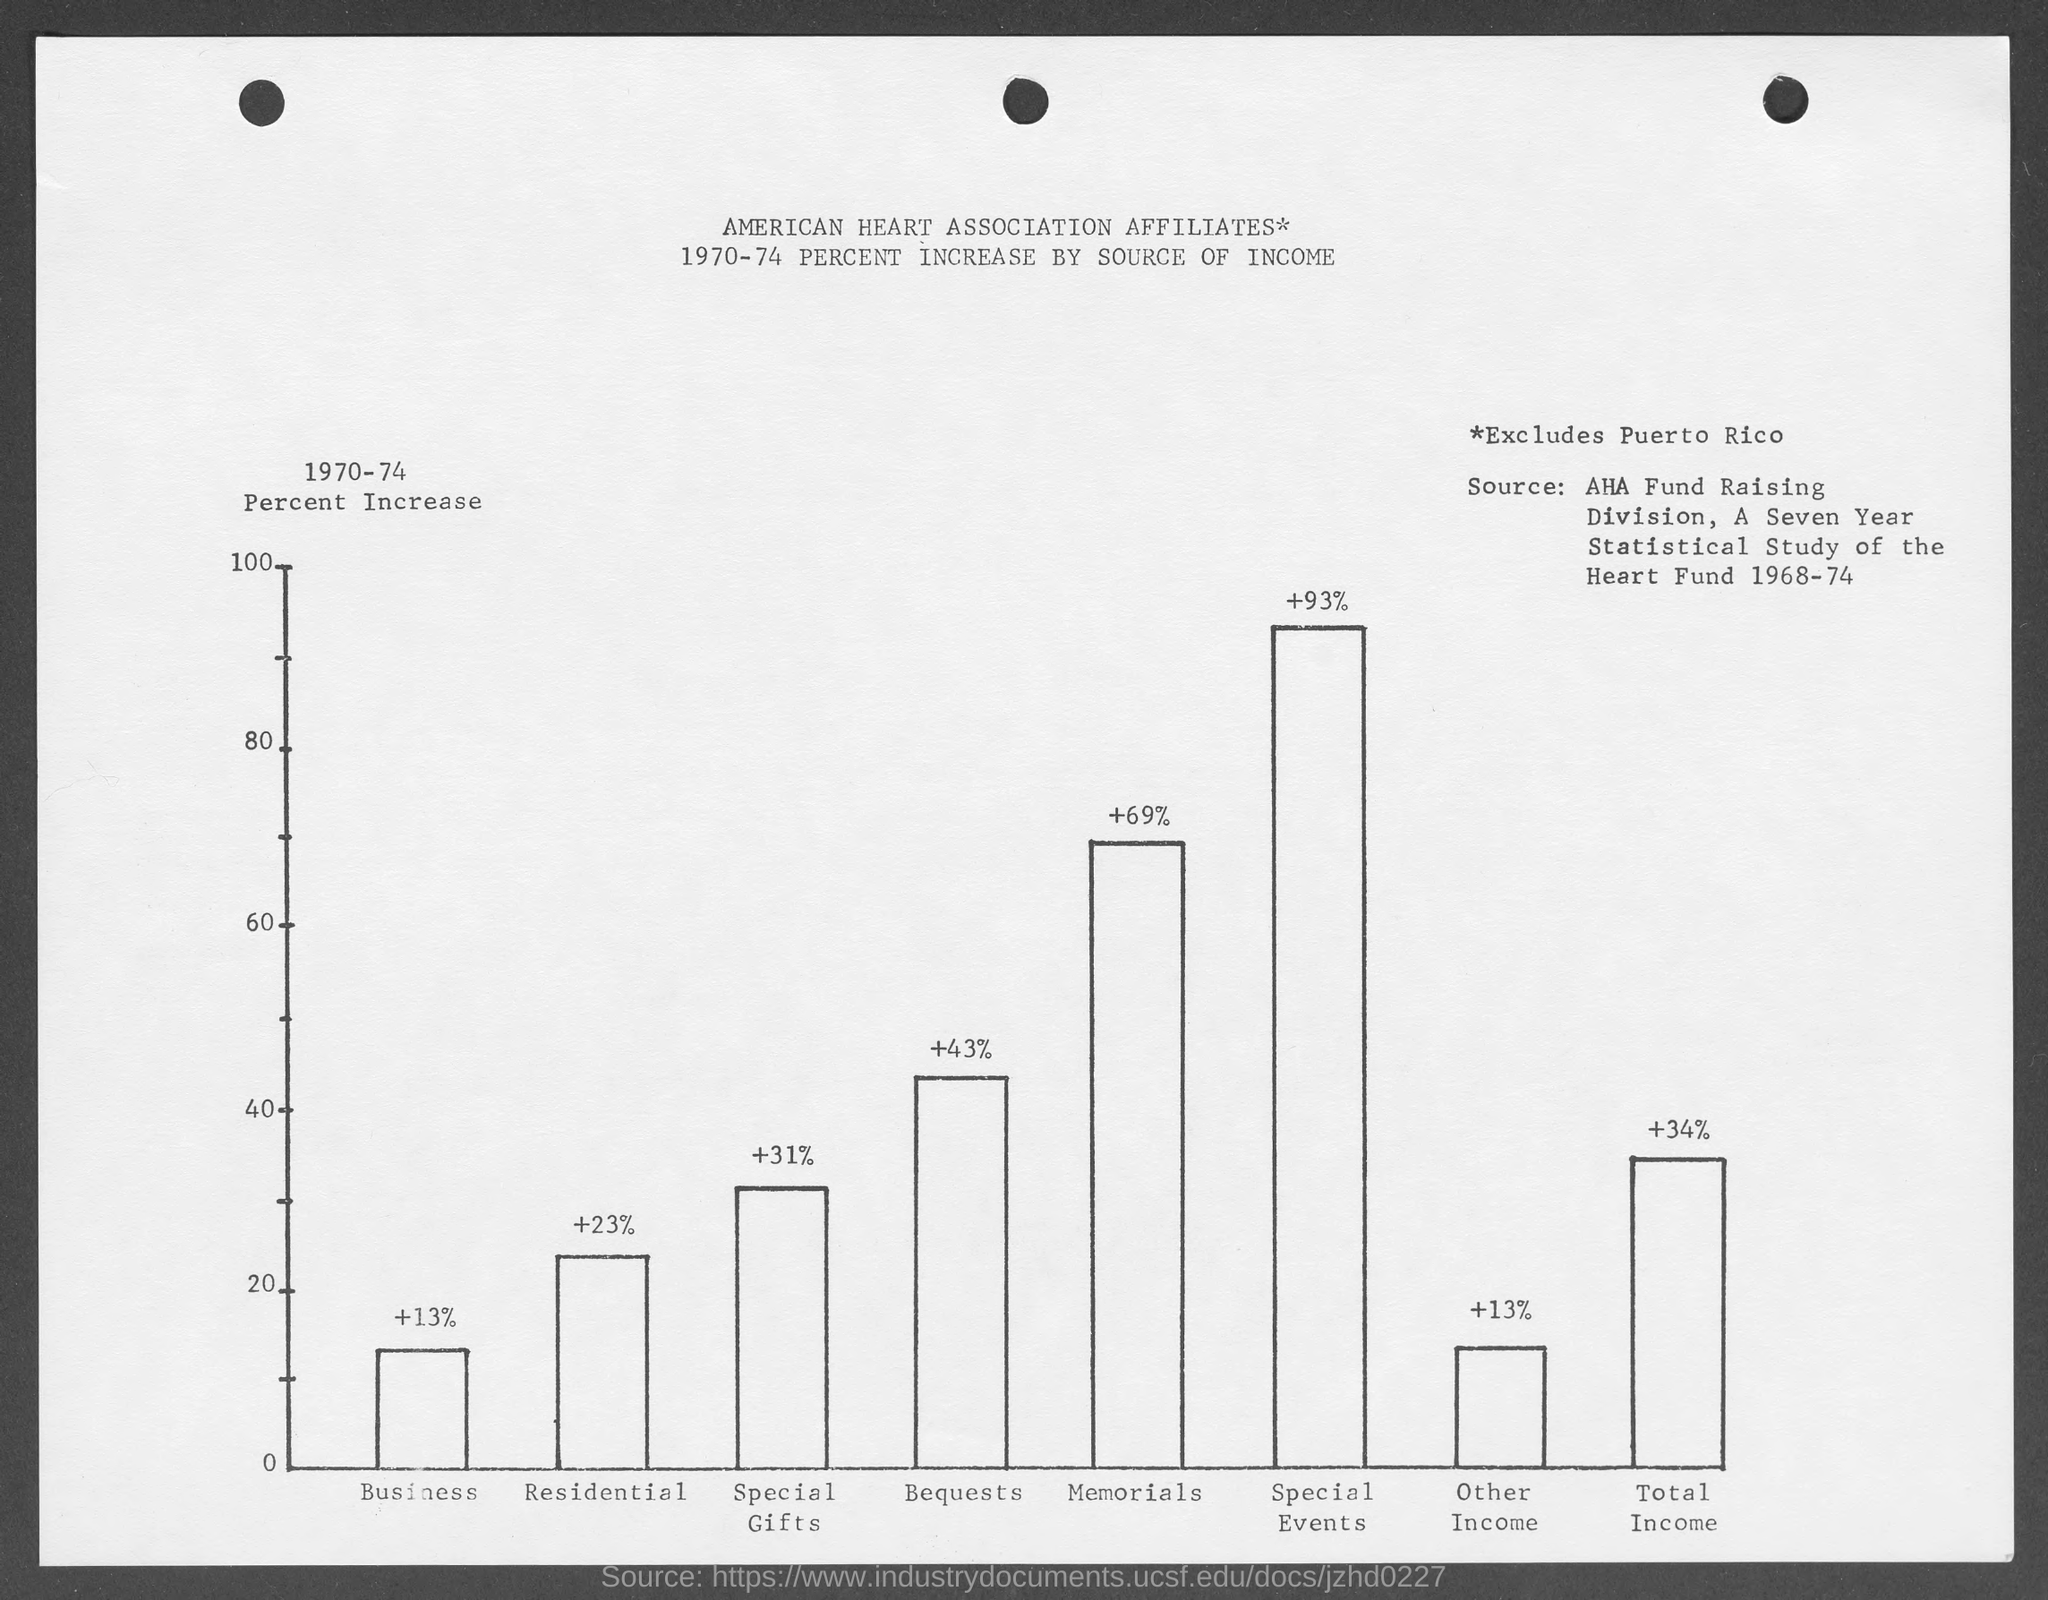Draw attention to some important aspects in this diagram. The percentage increase in special gifts from the given graph is from 1970-74. The percent increase is 31%. The given graph shows the total income of a business from 1970-74 and the percentage increase in income by source. The source with the highest percentage increase is [insert percentage increase]. The graph shows the percentage increase in special events of business from 1970 to 1974, with the source mentioned as "mentioned in the given graph". Based on this information, the percentage increase can be calculated as 93%. The graph shows the percentage increase in business income from 1970-74, with a 13% increase from the source mentioned. The given graph shows a percentage increase in bequests from 1970 to 1974, with the source of businesses contributing to the increase of 43%. 